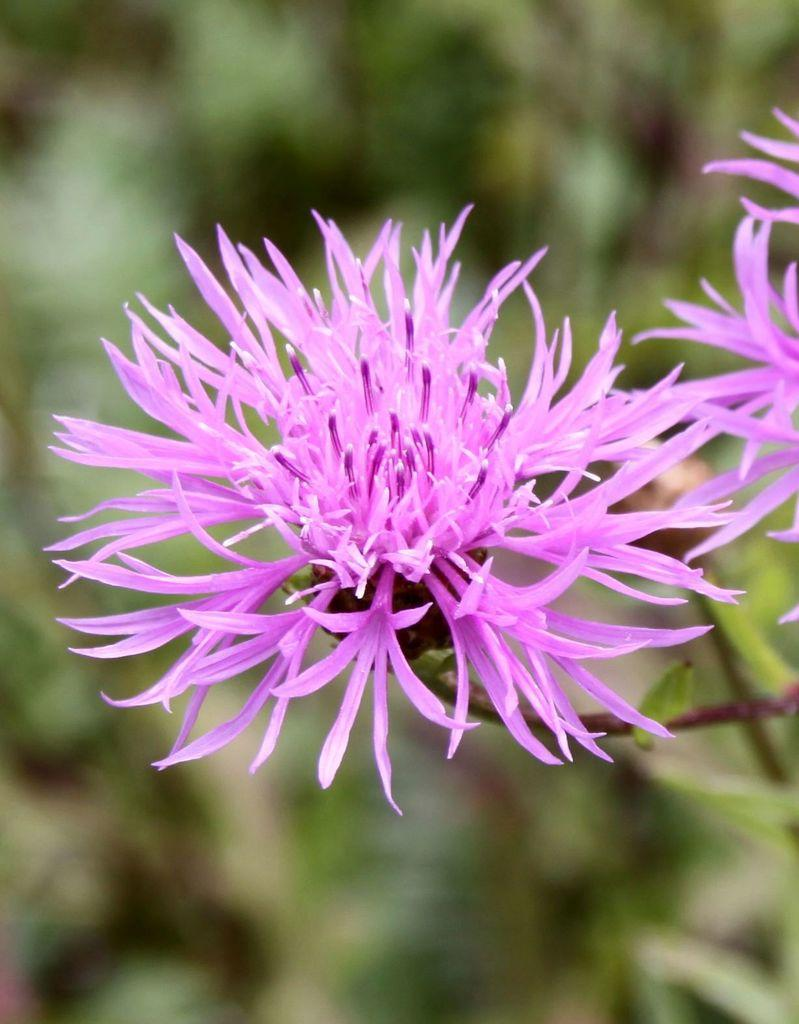What type of plants are in the image? There are flowers in the image. How are the flowers attached to the stems? The flowers are on stems. Can you describe the background of the image? The background of the image is blurry. How much money is being exchanged between the flowers in the image? There is no money being exchanged in the image; it features flowers on stems with a blurry background. 